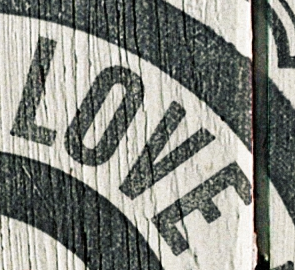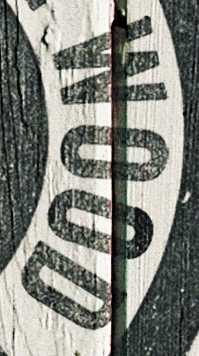What words are shown in these images in order, separated by a semicolon? LOVE; WOOD 